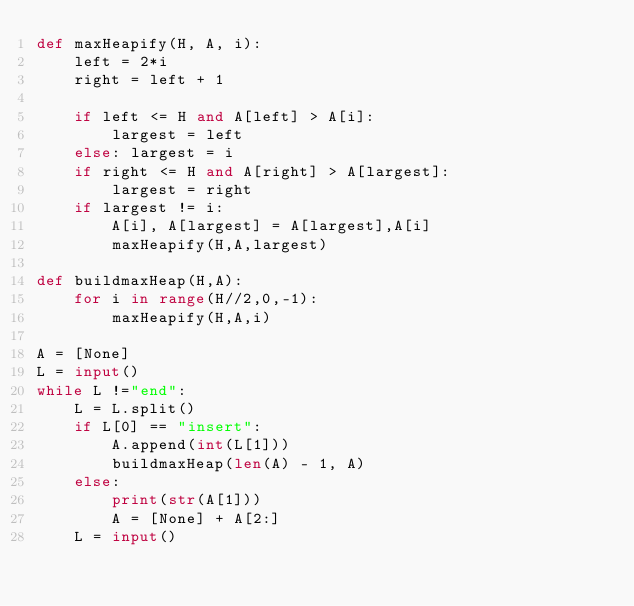Convert code to text. <code><loc_0><loc_0><loc_500><loc_500><_Python_>def maxHeapify(H, A, i):
    left = 2*i
    right = left + 1
 
    if left <= H and A[left] > A[i]:
        largest = left
    else: largest = i
    if right <= H and A[right] > A[largest]:
        largest = right
    if largest != i:
        A[i], A[largest] = A[largest],A[i]
        maxHeapify(H,A,largest)
 
def buildmaxHeap(H,A):
    for i in range(H//2,0,-1):
        maxHeapify(H,A,i)

A = [None]
L = input()
while L !="end":
    L = L.split()
    if L[0] == "insert":
        A.append(int(L[1]))
        buildmaxHeap(len(A) - 1, A)
    else:
        print(str(A[1]))
        A = [None] + A[2:]
    L = input()</code> 